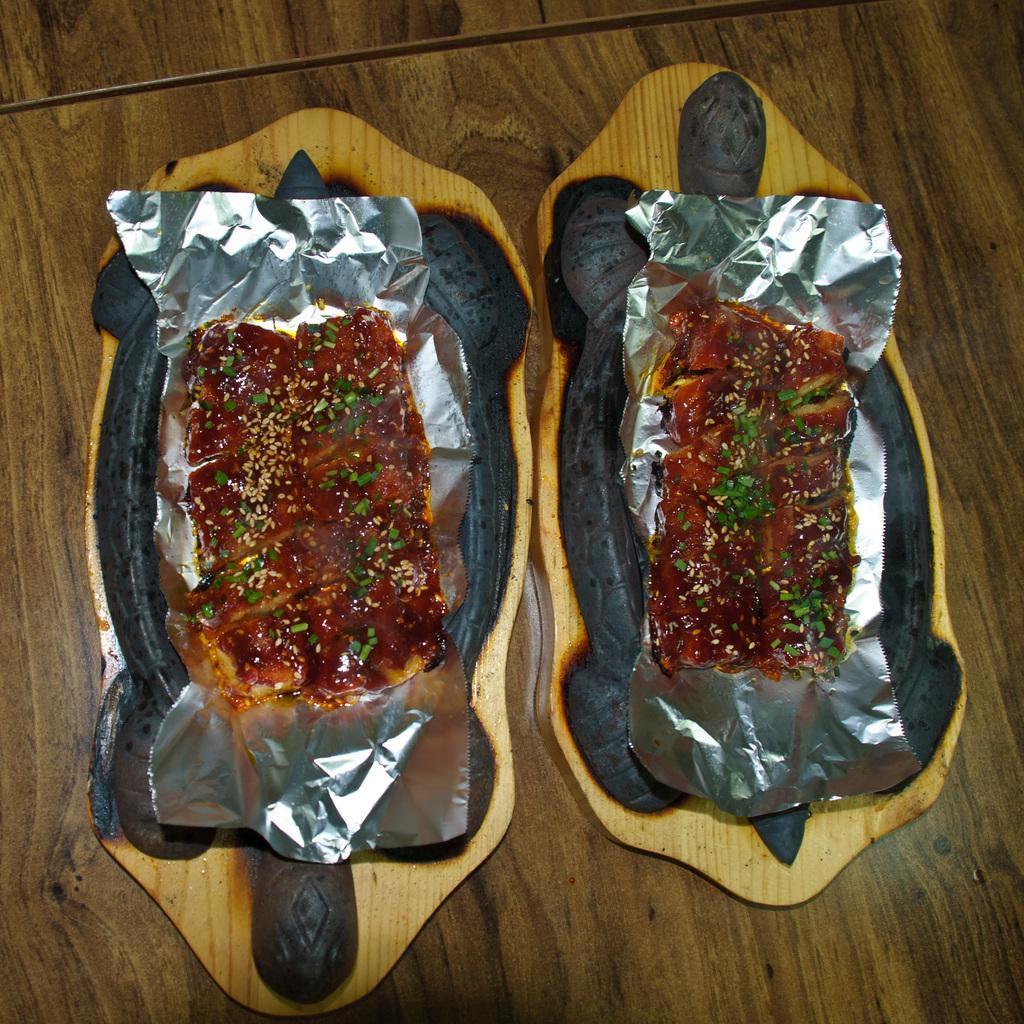What type of food can be seen in the image? There is food in the image, topped with grains and peas. How is the food arranged or presented? The food is placed on an aluminum foil and in a plate. Where is the plate with the food located? The plate with the food is placed on a table. What type of animal can be seen taking a voyage through the air in the image? There is no animal or voyage through the air depicted in the image; it features food on a plate. 